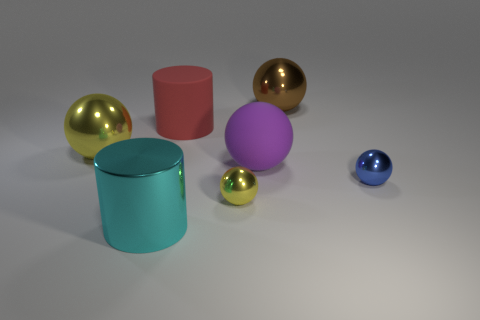What number of large purple objects have the same shape as the big red rubber object?
Keep it short and to the point. 0. What is the color of the small metal object to the left of the large metal object behind the large cylinder that is behind the big purple matte ball?
Provide a short and direct response. Yellow. Does the tiny object that is on the left side of the large purple thing have the same material as the large cylinder that is behind the large cyan cylinder?
Provide a succinct answer. No. What number of objects are either metal objects in front of the large yellow sphere or green matte blocks?
Your response must be concise. 3. What number of objects are either red matte things or balls that are to the right of the large matte sphere?
Your answer should be compact. 3. How many red matte objects have the same size as the brown shiny thing?
Make the answer very short. 1. Are there fewer red objects that are in front of the big yellow object than objects that are to the left of the cyan object?
Offer a very short reply. Yes. How many metal things are either small spheres or balls?
Offer a very short reply. 4. What is the shape of the big red object?
Make the answer very short. Cylinder. What is the material of the red thing that is the same size as the cyan thing?
Give a very brief answer. Rubber. 